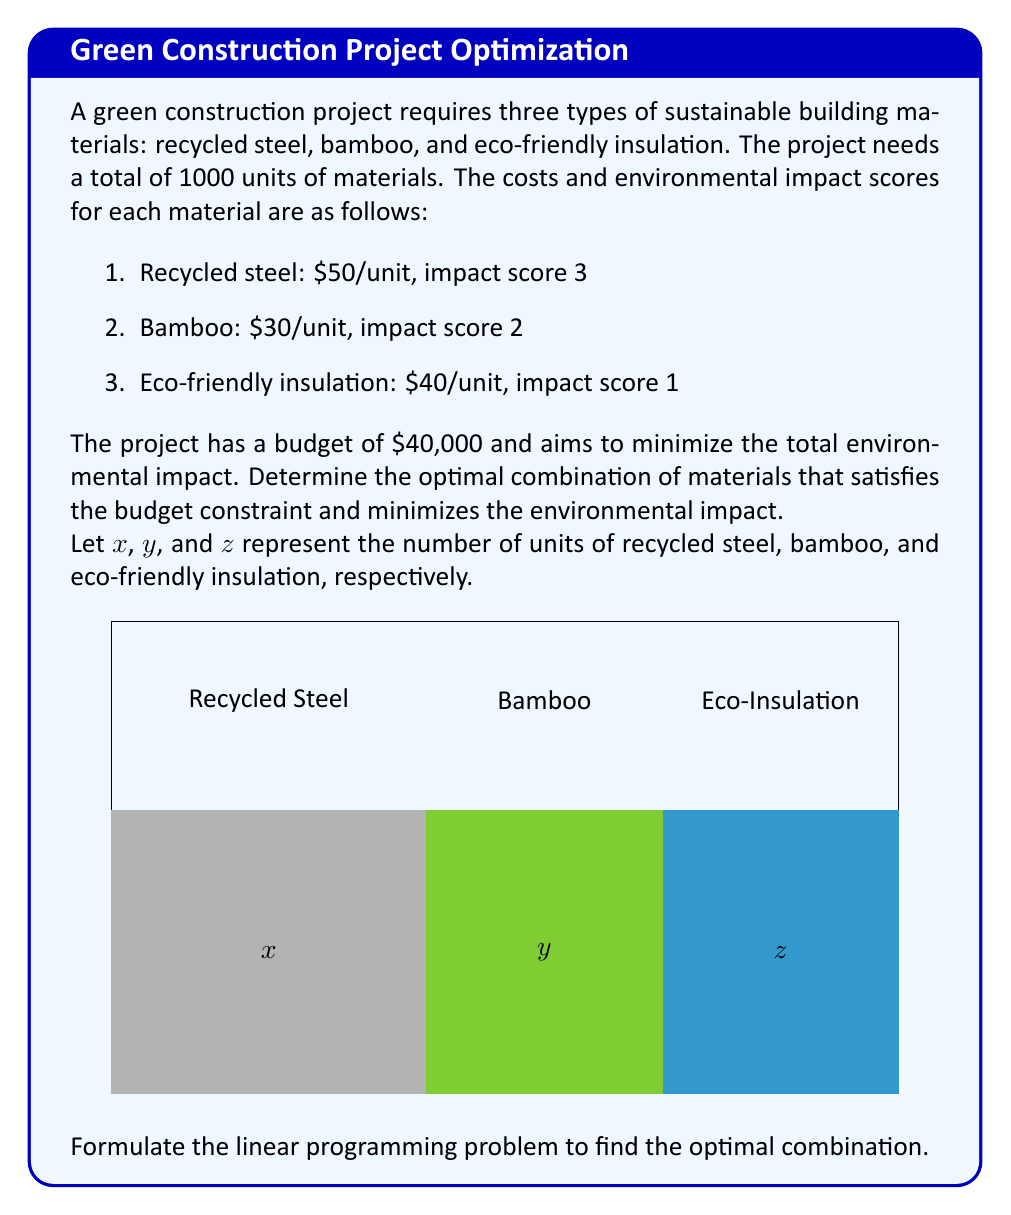Give your solution to this math problem. To solve this optimization problem, we'll follow these steps:

1. Define the objective function
2. Set up the constraints
3. Formulate the linear programming problem

Step 1: Define the objective function

We want to minimize the total environmental impact. The impact score for each material is multiplied by the number of units:

$$\text{Minimize } 3x + 2y + z$$

Step 2: Set up the constraints

a) Budget constraint:
   $$50x + 30y + 40z \leq 40000$$

b) Total material constraint:
   $$x + y + z = 1000$$

c) Non-negativity constraints:
   $$x \geq 0, y \geq 0, z \geq 0$$

Step 3: Formulate the linear programming problem

Combining the objective function and constraints, we get:

$$\text{Minimize } 3x + 2y + z$$
$$\text{Subject to:}$$
$$50x + 30y + 40z \leq 40000$$
$$x + y + z = 1000$$
$$x \geq 0, y \geq 0, z \geq 0$$

This linear programming problem can be solved using methods such as the simplex algorithm or interior point methods. The solution will provide the optimal values for x, y, and z, representing the number of units for each material that minimizes the environmental impact while satisfying the budget and total material constraints.
Answer: $$\begin{aligned}
\text{Minimize } & 3x + 2y + z \\
\text{Subject to:} & \\
& 50x + 30y + 40z \leq 40000 \\
& x + y + z = 1000 \\
& x, y, z \geq 0
\end{aligned}$$ 